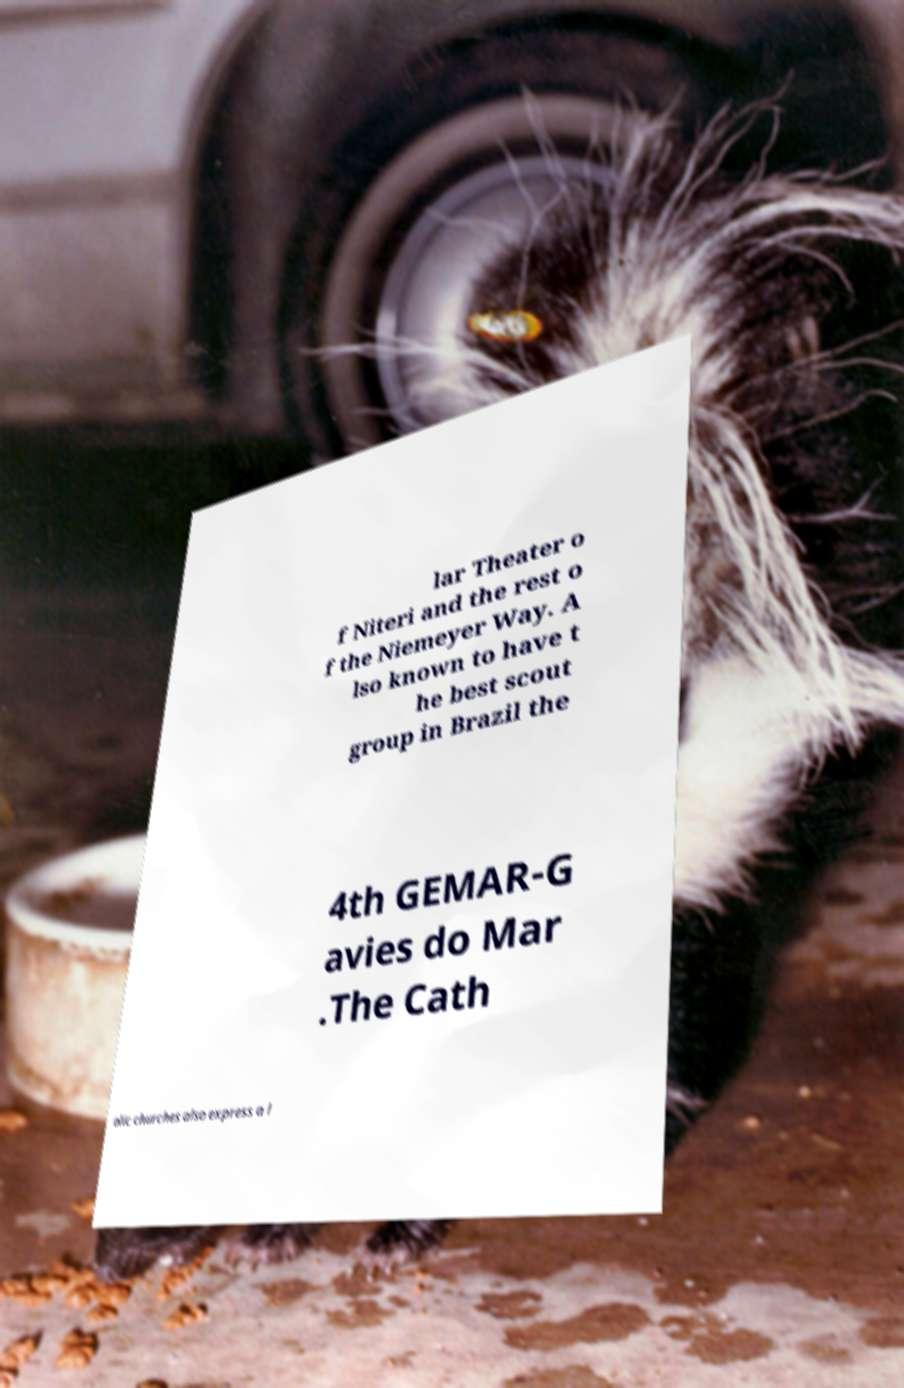Could you assist in decoding the text presented in this image and type it out clearly? lar Theater o f Niteri and the rest o f the Niemeyer Way. A lso known to have t he best scout group in Brazil the 4th GEMAR-G avies do Mar .The Cath olic churches also express a l 